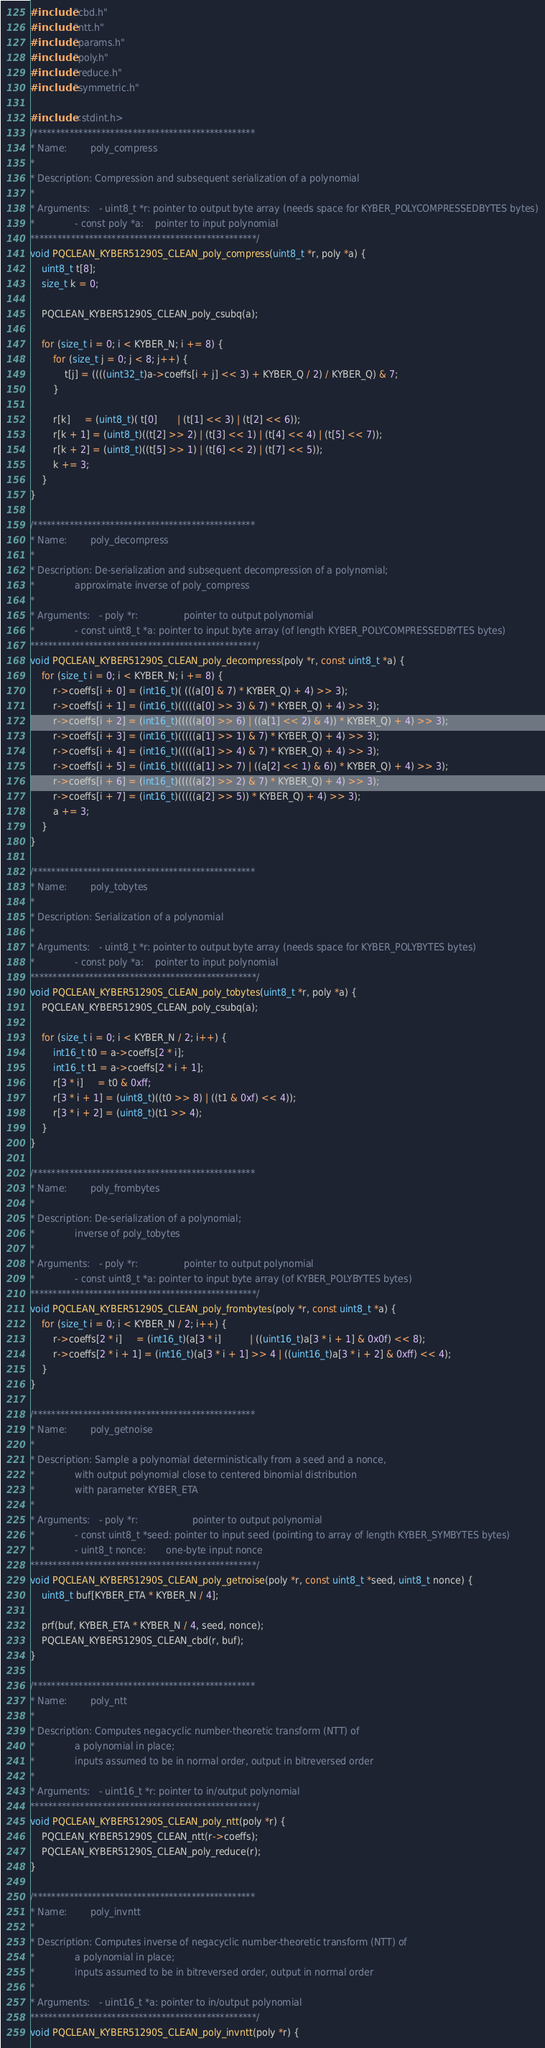Convert code to text. <code><loc_0><loc_0><loc_500><loc_500><_C_>#include "cbd.h"
#include "ntt.h"
#include "params.h"
#include "poly.h"
#include "reduce.h"
#include "symmetric.h"

#include <stdint.h>
/*************************************************
* Name:        poly_compress
*
* Description: Compression and subsequent serialization of a polynomial
*
* Arguments:   - uint8_t *r: pointer to output byte array (needs space for KYBER_POLYCOMPRESSEDBYTES bytes)
*              - const poly *a:    pointer to input polynomial
**************************************************/
void PQCLEAN_KYBER51290S_CLEAN_poly_compress(uint8_t *r, poly *a) {
    uint8_t t[8];
    size_t k = 0;

    PQCLEAN_KYBER51290S_CLEAN_poly_csubq(a);

    for (size_t i = 0; i < KYBER_N; i += 8) {
        for (size_t j = 0; j < 8; j++) {
            t[j] = ((((uint32_t)a->coeffs[i + j] << 3) + KYBER_Q / 2) / KYBER_Q) & 7;
        }

        r[k]     = (uint8_t)( t[0]       | (t[1] << 3) | (t[2] << 6));
        r[k + 1] = (uint8_t)((t[2] >> 2) | (t[3] << 1) | (t[4] << 4) | (t[5] << 7));
        r[k + 2] = (uint8_t)((t[5] >> 1) | (t[6] << 2) | (t[7] << 5));
        k += 3;
    }
}

/*************************************************
* Name:        poly_decompress
*
* Description: De-serialization and subsequent decompression of a polynomial;
*              approximate inverse of poly_compress
*
* Arguments:   - poly *r:                pointer to output polynomial
*              - const uint8_t *a: pointer to input byte array (of length KYBER_POLYCOMPRESSEDBYTES bytes)
**************************************************/
void PQCLEAN_KYBER51290S_CLEAN_poly_decompress(poly *r, const uint8_t *a) {
    for (size_t i = 0; i < KYBER_N; i += 8) {
        r->coeffs[i + 0] = (int16_t)( (((a[0] & 7) * KYBER_Q) + 4) >> 3);
        r->coeffs[i + 1] = (int16_t)(((((a[0] >> 3) & 7) * KYBER_Q) + 4) >> 3);
        r->coeffs[i + 2] = (int16_t)(((((a[0] >> 6) | ((a[1] << 2) & 4)) * KYBER_Q) + 4) >> 3);
        r->coeffs[i + 3] = (int16_t)(((((a[1] >> 1) & 7) * KYBER_Q) + 4) >> 3);
        r->coeffs[i + 4] = (int16_t)(((((a[1] >> 4) & 7) * KYBER_Q) + 4) >> 3);
        r->coeffs[i + 5] = (int16_t)(((((a[1] >> 7) | ((a[2] << 1) & 6)) * KYBER_Q) + 4) >> 3);
        r->coeffs[i + 6] = (int16_t)(((((a[2] >> 2) & 7) * KYBER_Q) + 4) >> 3);
        r->coeffs[i + 7] = (int16_t)(((((a[2] >> 5)) * KYBER_Q) + 4) >> 3);
        a += 3;
    }
}

/*************************************************
* Name:        poly_tobytes
*
* Description: Serialization of a polynomial
*
* Arguments:   - uint8_t *r: pointer to output byte array (needs space for KYBER_POLYBYTES bytes)
*              - const poly *a:    pointer to input polynomial
**************************************************/
void PQCLEAN_KYBER51290S_CLEAN_poly_tobytes(uint8_t *r, poly *a) {
    PQCLEAN_KYBER51290S_CLEAN_poly_csubq(a);

    for (size_t i = 0; i < KYBER_N / 2; i++) {
        int16_t t0 = a->coeffs[2 * i];
        int16_t t1 = a->coeffs[2 * i + 1];
        r[3 * i]     = t0 & 0xff;
        r[3 * i + 1] = (uint8_t)((t0 >> 8) | ((t1 & 0xf) << 4));
        r[3 * i + 2] = (uint8_t)(t1 >> 4);
    }
}

/*************************************************
* Name:        poly_frombytes
*
* Description: De-serialization of a polynomial;
*              inverse of poly_tobytes
*
* Arguments:   - poly *r:                pointer to output polynomial
*              - const uint8_t *a: pointer to input byte array (of KYBER_POLYBYTES bytes)
**************************************************/
void PQCLEAN_KYBER51290S_CLEAN_poly_frombytes(poly *r, const uint8_t *a) {
    for (size_t i = 0; i < KYBER_N / 2; i++) {
        r->coeffs[2 * i]     = (int16_t)(a[3 * i]          | ((uint16_t)a[3 * i + 1] & 0x0f) << 8);
        r->coeffs[2 * i + 1] = (int16_t)(a[3 * i + 1] >> 4 | ((uint16_t)a[3 * i + 2] & 0xff) << 4);
    }
}

/*************************************************
* Name:        poly_getnoise
*
* Description: Sample a polynomial deterministically from a seed and a nonce,
*              with output polynomial close to centered binomial distribution
*              with parameter KYBER_ETA
*
* Arguments:   - poly *r:                   pointer to output polynomial
*              - const uint8_t *seed: pointer to input seed (pointing to array of length KYBER_SYMBYTES bytes)
*              - uint8_t nonce:       one-byte input nonce
**************************************************/
void PQCLEAN_KYBER51290S_CLEAN_poly_getnoise(poly *r, const uint8_t *seed, uint8_t nonce) {
    uint8_t buf[KYBER_ETA * KYBER_N / 4];

    prf(buf, KYBER_ETA * KYBER_N / 4, seed, nonce);
    PQCLEAN_KYBER51290S_CLEAN_cbd(r, buf);
}

/*************************************************
* Name:        poly_ntt
*
* Description: Computes negacyclic number-theoretic transform (NTT) of
*              a polynomial in place;
*              inputs assumed to be in normal order, output in bitreversed order
*
* Arguments:   - uint16_t *r: pointer to in/output polynomial
**************************************************/
void PQCLEAN_KYBER51290S_CLEAN_poly_ntt(poly *r) {
    PQCLEAN_KYBER51290S_CLEAN_ntt(r->coeffs);
    PQCLEAN_KYBER51290S_CLEAN_poly_reduce(r);
}

/*************************************************
* Name:        poly_invntt
*
* Description: Computes inverse of negacyclic number-theoretic transform (NTT) of
*              a polynomial in place;
*              inputs assumed to be in bitreversed order, output in normal order
*
* Arguments:   - uint16_t *a: pointer to in/output polynomial
**************************************************/
void PQCLEAN_KYBER51290S_CLEAN_poly_invntt(poly *r) {</code> 